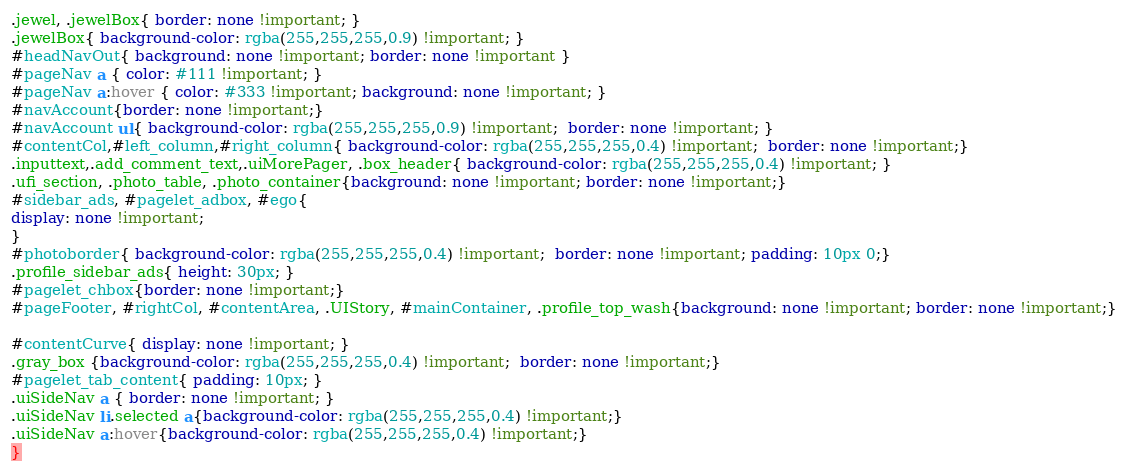Convert code to text. <code><loc_0><loc_0><loc_500><loc_500><_CSS_>.jewel, .jewelBox{ border: none !important; }
.jewelBox{ background-color: rgba(255,255,255,0.9) !important; }
#headNavOut{ background: none !important; border: none !important }
#pageNav a { color: #111 !important; }
#pageNav a:hover { color: #333 !important; background: none !important; }
#navAccount{border: none !important;}
#navAccount ul{ background-color: rgba(255,255,255,0.9) !important;  border: none !important; }
#contentCol,#left_column,#right_column{ background-color: rgba(255,255,255,0.4) !important;  border: none !important;}
.inputtext,.add_comment_text,.uiMorePager, .box_header{ background-color: rgba(255,255,255,0.4) !important; }
.ufi_section, .photo_table, .photo_container{background: none !important; border: none !important;}
#sidebar_ads, #pagelet_adbox, #ego{
display: none !important;
}
#photoborder{ background-color: rgba(255,255,255,0.4) !important;  border: none !important; padding: 10px 0;}
.profile_sidebar_ads{ height: 30px; }
#pagelet_chbox{border: none !important;}
#pageFooter, #rightCol, #contentArea, .UIStory, #mainContainer, .profile_top_wash{background: none !important; border: none !important;}

#contentCurve{ display: none !important; }
.gray_box {background-color: rgba(255,255,255,0.4) !important;  border: none !important;}
#pagelet_tab_content{ padding: 10px; }
.uiSideNav a { border: none !important; }
.uiSideNav li.selected a{background-color: rgba(255,255,255,0.4) !important;}
.uiSideNav a:hover{background-color: rgba(255,255,255,0.4) !important;}
}
</code> 